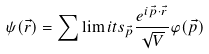Convert formula to latex. <formula><loc_0><loc_0><loc_500><loc_500>\psi ( \vec { r } ) = \sum \lim i t s _ { \vec { p } } { \frac { e ^ { i \vec { p } \cdot \vec { r } } } { \sqrt { V } } \varphi ( \vec { p } ) }</formula> 